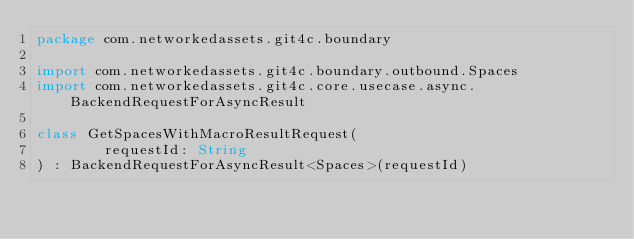Convert code to text. <code><loc_0><loc_0><loc_500><loc_500><_Kotlin_>package com.networkedassets.git4c.boundary

import com.networkedassets.git4c.boundary.outbound.Spaces
import com.networkedassets.git4c.core.usecase.async.BackendRequestForAsyncResult

class GetSpacesWithMacroResultRequest(
        requestId: String
) : BackendRequestForAsyncResult<Spaces>(requestId)</code> 